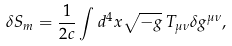<formula> <loc_0><loc_0><loc_500><loc_500>\delta S _ { m } = \frac { 1 } { 2 c } \int d ^ { 4 } x \sqrt { - g } \, T _ { \mu \nu } \delta g ^ { \mu \nu } ,</formula> 